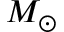Convert formula to latex. <formula><loc_0><loc_0><loc_500><loc_500>M _ { \odot }</formula> 